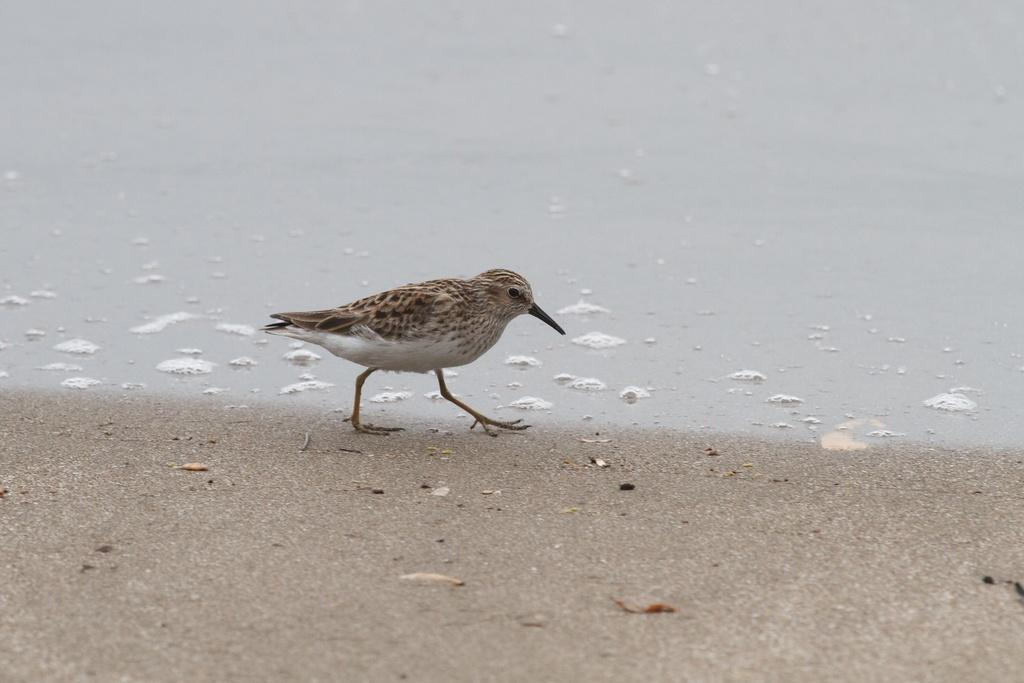What type of animal can be seen in the image? There is a bird in the image. What is the bird doing in the image? The bird is walking. What can be seen in the background of the image? There is water visible in the image. What color is the bird's brain in the image? There is no information about the bird's brain in the image, and therefore we cannot determine its color. 